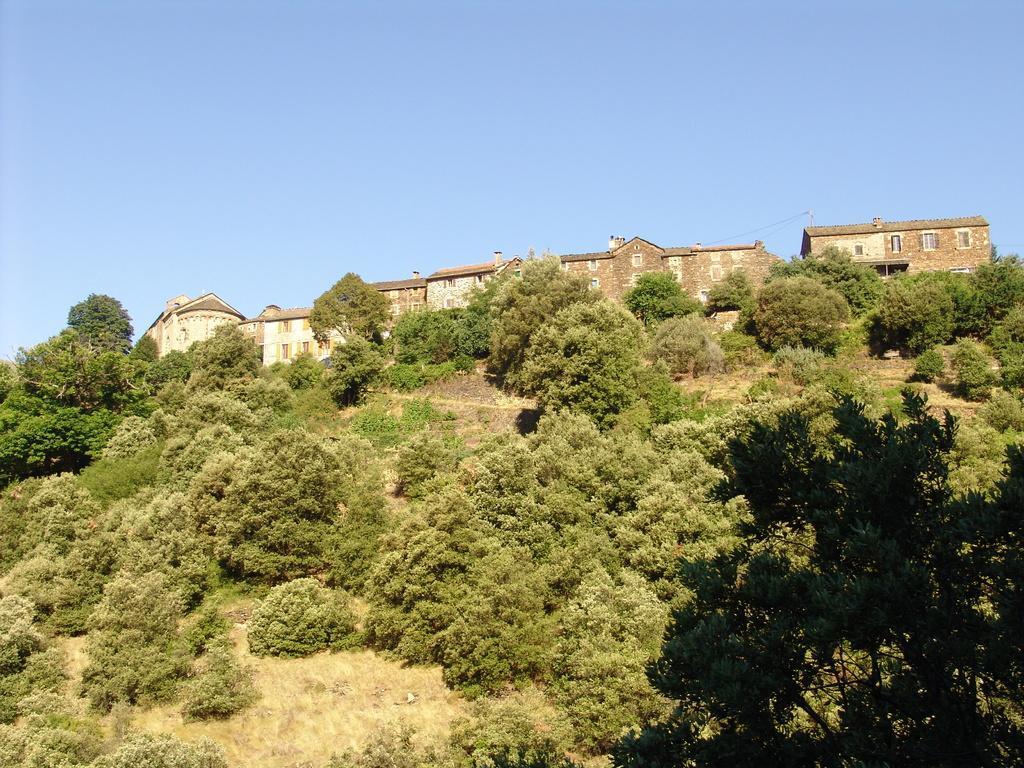In one or two sentences, can you explain what this image depicts? In this image I can see there are buildings. And in front of the building there are trees. And at the top there is a sky. 